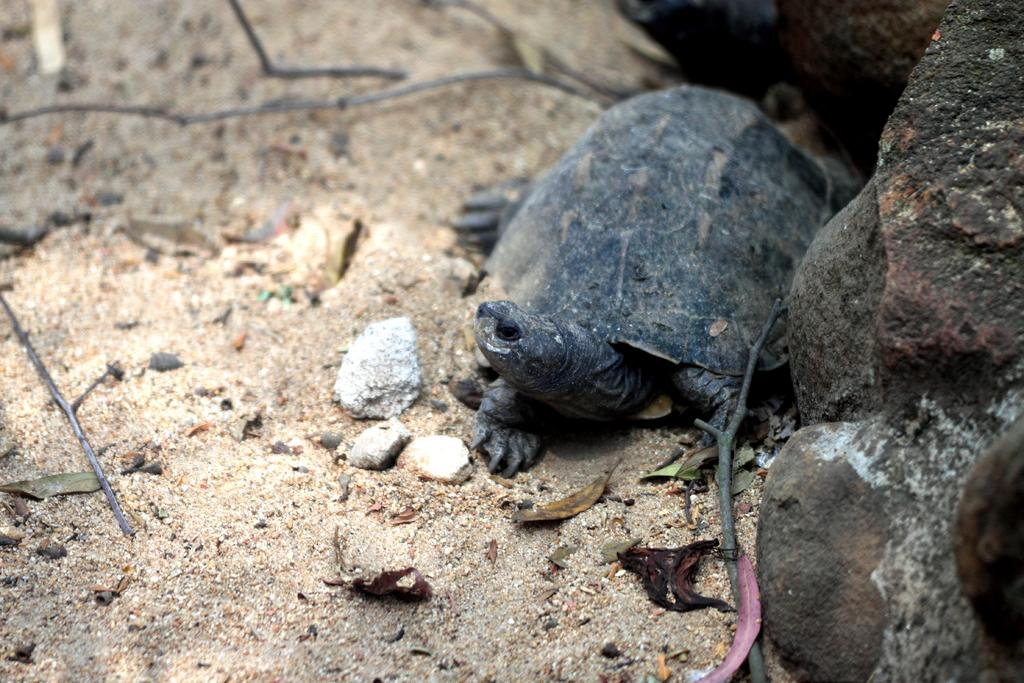What is the main subject in the center of the image? There is a tortoise in the center of the image. What can be seen on the right side of the image? There are rocks on the right side of the image. What is visible in the background of the image? Stones, dry leaves, and the ground are visible in the background of the image. How does the grandfather interact with the tortoise in the image? There is no grandfather present in the image; it only features a tortoise, rocks, stones, dry leaves, and the ground. What type of lumber is being used to build the tortoise's shelter in the image? There is no lumber or shelter present in the image; it only features a tortoise, rocks, stones, dry leaves, and the ground. 